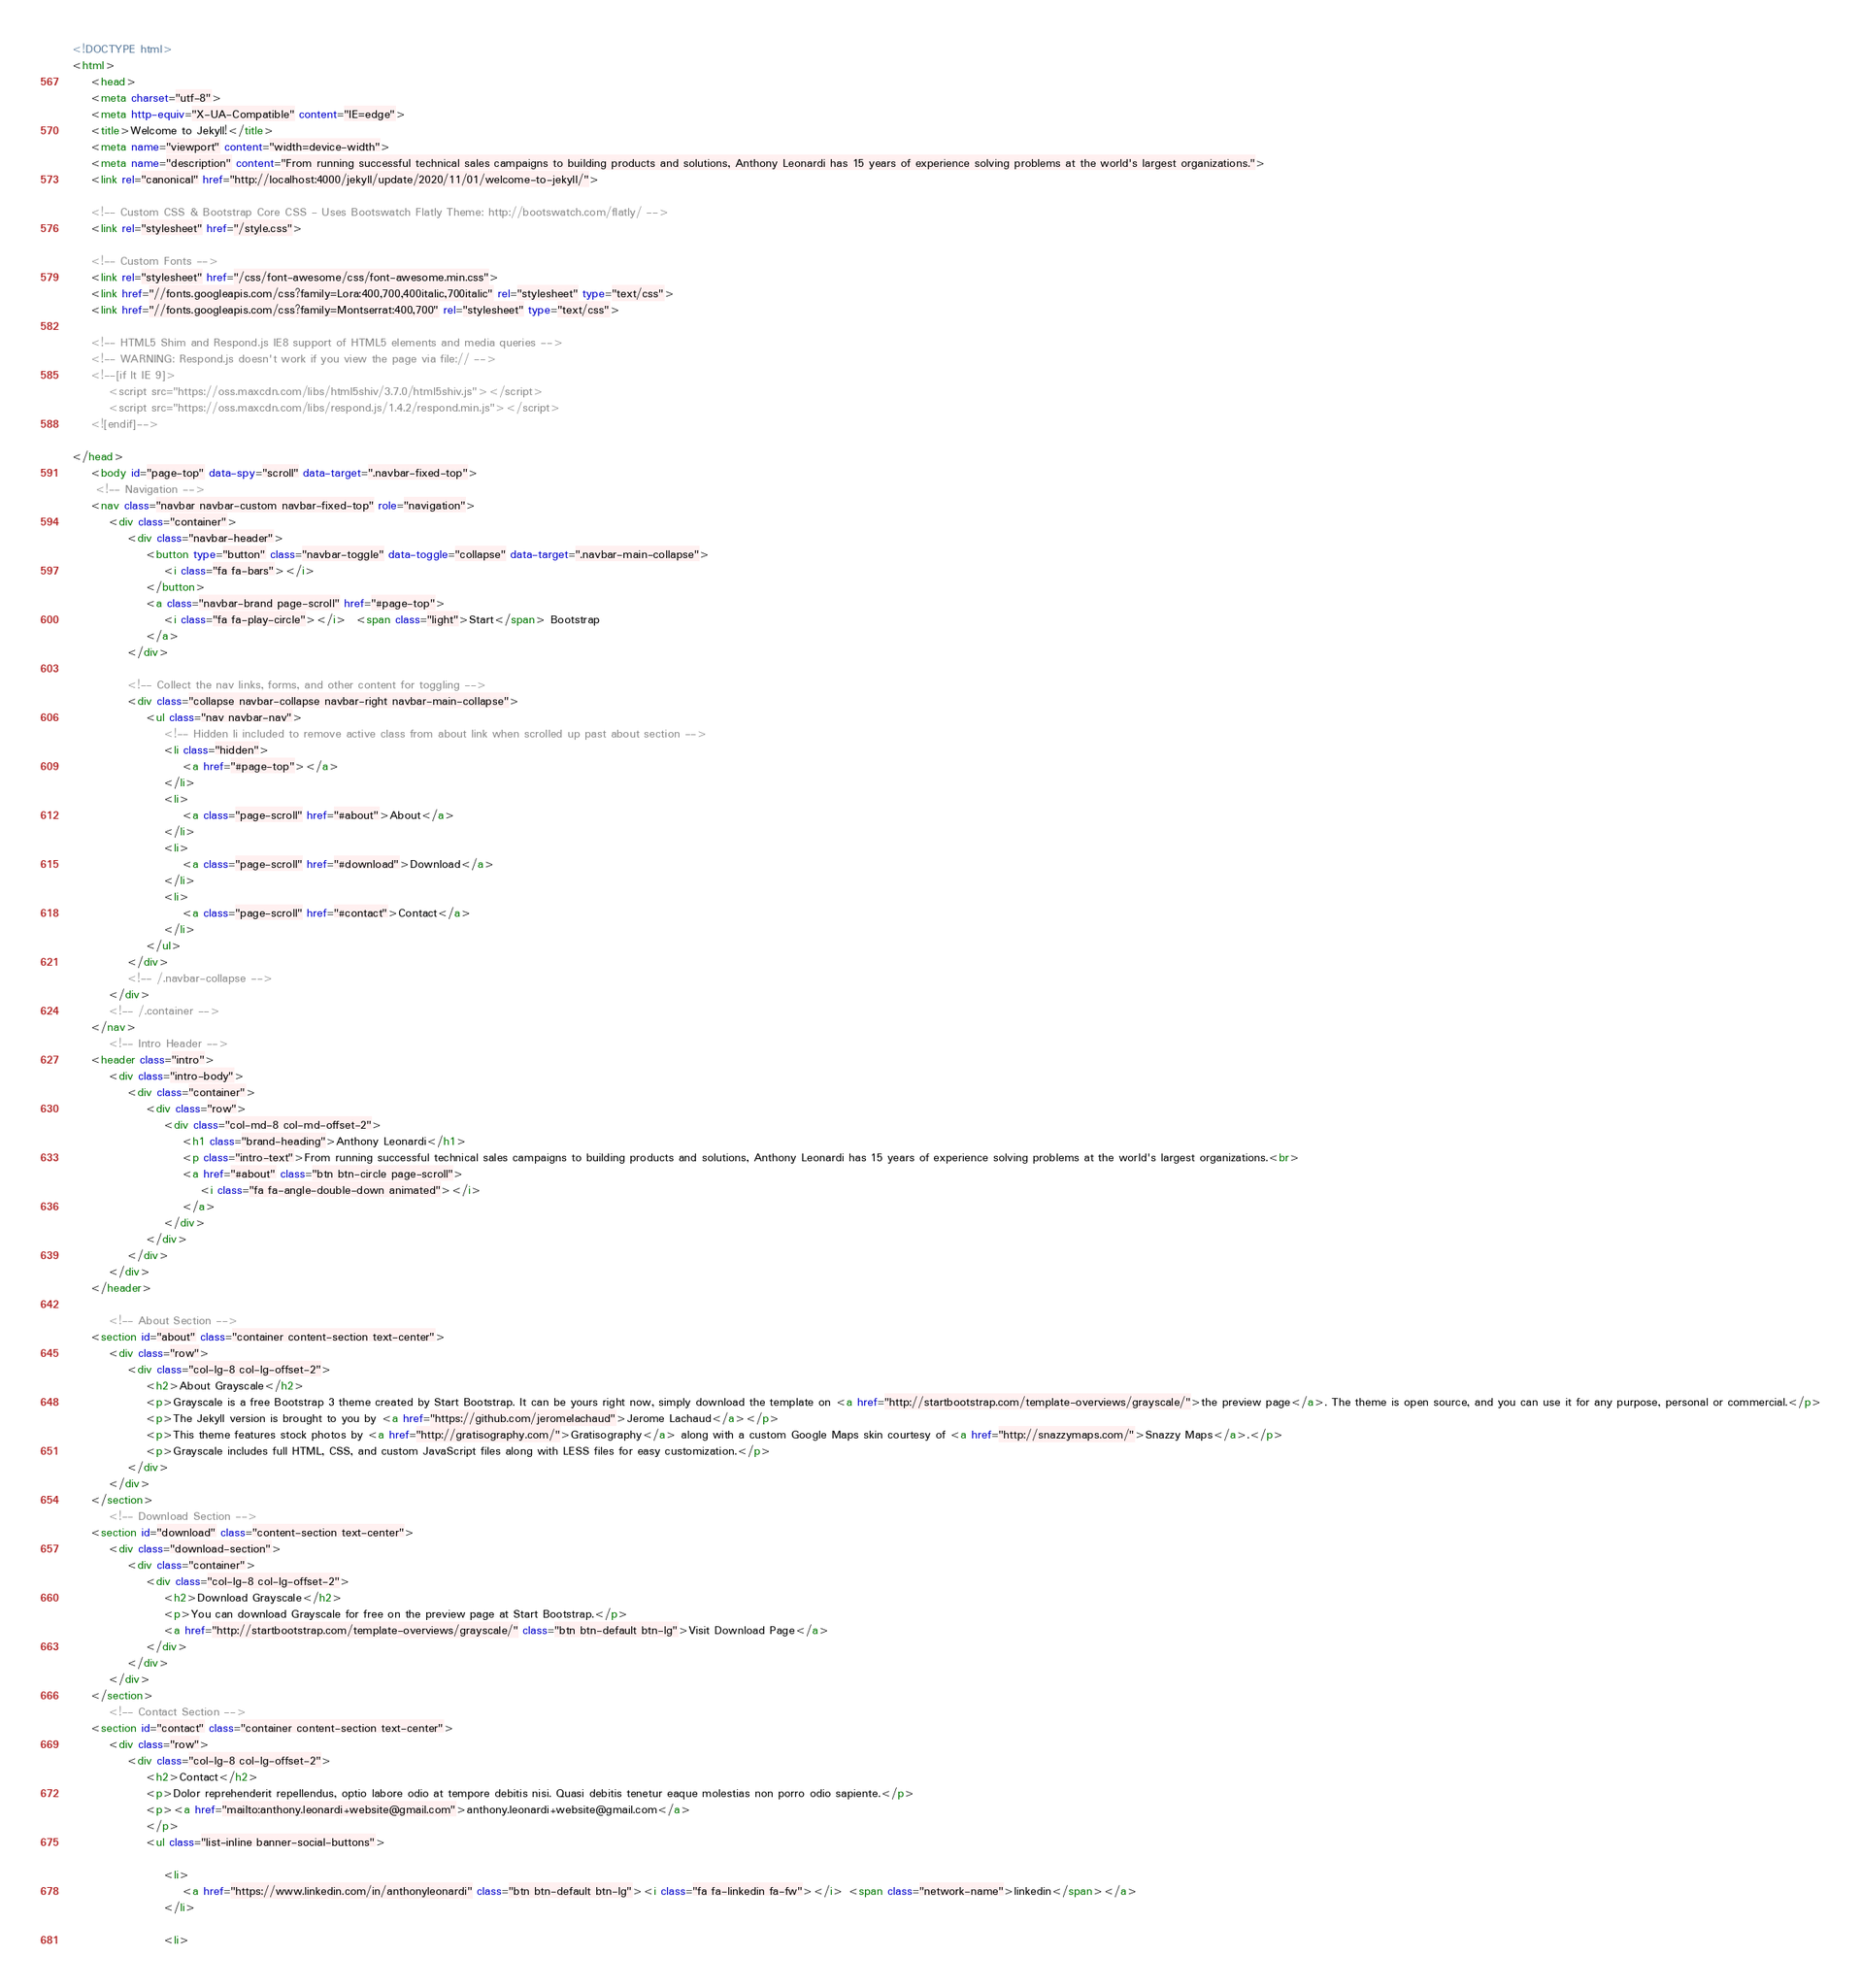<code> <loc_0><loc_0><loc_500><loc_500><_HTML_><!DOCTYPE html>
<html>
    <head>
    <meta charset="utf-8">
    <meta http-equiv="X-UA-Compatible" content="IE=edge">
    <title>Welcome to Jekyll!</title>
    <meta name="viewport" content="width=device-width">
    <meta name="description" content="From running successful technical sales campaigns to building products and solutions, Anthony Leonardi has 15 years of experience solving problems at the world's largest organizations.">
    <link rel="canonical" href="http://localhost:4000/jekyll/update/2020/11/01/welcome-to-jekyll/">

    <!-- Custom CSS & Bootstrap Core CSS - Uses Bootswatch Flatly Theme: http://bootswatch.com/flatly/ -->
    <link rel="stylesheet" href="/style.css">

    <!-- Custom Fonts -->
    <link rel="stylesheet" href="/css/font-awesome/css/font-awesome.min.css">
    <link href="//fonts.googleapis.com/css?family=Lora:400,700,400italic,700italic" rel="stylesheet" type="text/css">
    <link href="//fonts.googleapis.com/css?family=Montserrat:400,700" rel="stylesheet" type="text/css">

    <!-- HTML5 Shim and Respond.js IE8 support of HTML5 elements and media queries -->
    <!-- WARNING: Respond.js doesn't work if you view the page via file:// -->
    <!--[if lt IE 9]>
        <script src="https://oss.maxcdn.com/libs/html5shiv/3.7.0/html5shiv.js"></script>
        <script src="https://oss.maxcdn.com/libs/respond.js/1.4.2/respond.min.js"></script>
    <![endif]-->

</head>
    <body id="page-top" data-spy="scroll" data-target=".navbar-fixed-top">
     <!-- Navigation -->
    <nav class="navbar navbar-custom navbar-fixed-top" role="navigation">
        <div class="container">
            <div class="navbar-header">
                <button type="button" class="navbar-toggle" data-toggle="collapse" data-target=".navbar-main-collapse">
                    <i class="fa fa-bars"></i>
                </button>
                <a class="navbar-brand page-scroll" href="#page-top">
                    <i class="fa fa-play-circle"></i>  <span class="light">Start</span> Bootstrap
                </a>
            </div>

            <!-- Collect the nav links, forms, and other content for toggling -->
            <div class="collapse navbar-collapse navbar-right navbar-main-collapse">
                <ul class="nav navbar-nav">
                    <!-- Hidden li included to remove active class from about link when scrolled up past about section -->
                    <li class="hidden">
                        <a href="#page-top"></a>
                    </li>
                    <li>
                        <a class="page-scroll" href="#about">About</a>
                    </li>
                    <li>
                        <a class="page-scroll" href="#download">Download</a>
                    </li>
                    <li>
                        <a class="page-scroll" href="#contact">Contact</a>
                    </li>
                </ul>
            </div>
            <!-- /.navbar-collapse -->
        </div>
        <!-- /.container -->
    </nav>
        <!-- Intro Header -->
    <header class="intro">
        <div class="intro-body">
            <div class="container">
                <div class="row">
                    <div class="col-md-8 col-md-offset-2">
                        <h1 class="brand-heading">Anthony Leonardi</h1>
                        <p class="intro-text">From running successful technical sales campaigns to building products and solutions, Anthony Leonardi has 15 years of experience solving problems at the world's largest organizations.<br>
                        <a href="#about" class="btn btn-circle page-scroll">
                            <i class="fa fa-angle-double-down animated"></i>
                        </a>
                    </div>
                </div>
            </div>
        </div>
    </header>

        <!-- About Section -->
    <section id="about" class="container content-section text-center">
        <div class="row">
            <div class="col-lg-8 col-lg-offset-2">
                <h2>About Grayscale</h2>
                <p>Grayscale is a free Bootstrap 3 theme created by Start Bootstrap. It can be yours right now, simply download the template on <a href="http://startbootstrap.com/template-overviews/grayscale/">the preview page</a>. The theme is open source, and you can use it for any purpose, personal or commercial.</p>
                <p>The Jekyll version is brought to you by <a href="https://github.com/jeromelachaud">Jerome Lachaud</a></p>
                <p>This theme features stock photos by <a href="http://gratisography.com/">Gratisography</a> along with a custom Google Maps skin courtesy of <a href="http://snazzymaps.com/">Snazzy Maps</a>.</p>
                <p>Grayscale includes full HTML, CSS, and custom JavaScript files along with LESS files for easy customization.</p>
            </div>
        </div>
    </section>
        <!-- Download Section -->
    <section id="download" class="content-section text-center">
        <div class="download-section">
            <div class="container">
                <div class="col-lg-8 col-lg-offset-2">
                    <h2>Download Grayscale</h2>
                    <p>You can download Grayscale for free on the preview page at Start Bootstrap.</p>
                    <a href="http://startbootstrap.com/template-overviews/grayscale/" class="btn btn-default btn-lg">Visit Download Page</a>
                </div>
            </div>
        </div>
    </section>
        <!-- Contact Section -->
    <section id="contact" class="container content-section text-center">
        <div class="row">
            <div class="col-lg-8 col-lg-offset-2">
                <h2>Contact</h2>
                <p>Dolor reprehenderit repellendus, optio labore odio at tempore debitis nisi. Quasi debitis tenetur eaque molestias non porro odio sapiente.</p>
                <p><a href="mailto:anthony.leonardi+website@gmail.com">anthony.leonardi+website@gmail.com</a>
                </p>
                <ul class="list-inline banner-social-buttons">
                    
                    <li>
                        <a href="https://www.linkedin.com/in/anthonyleonardi" class="btn btn-default btn-lg"><i class="fa fa-linkedin fa-fw"></i> <span class="network-name">linkedin</span></a>
                    </li>
                    
                    <li></code> 